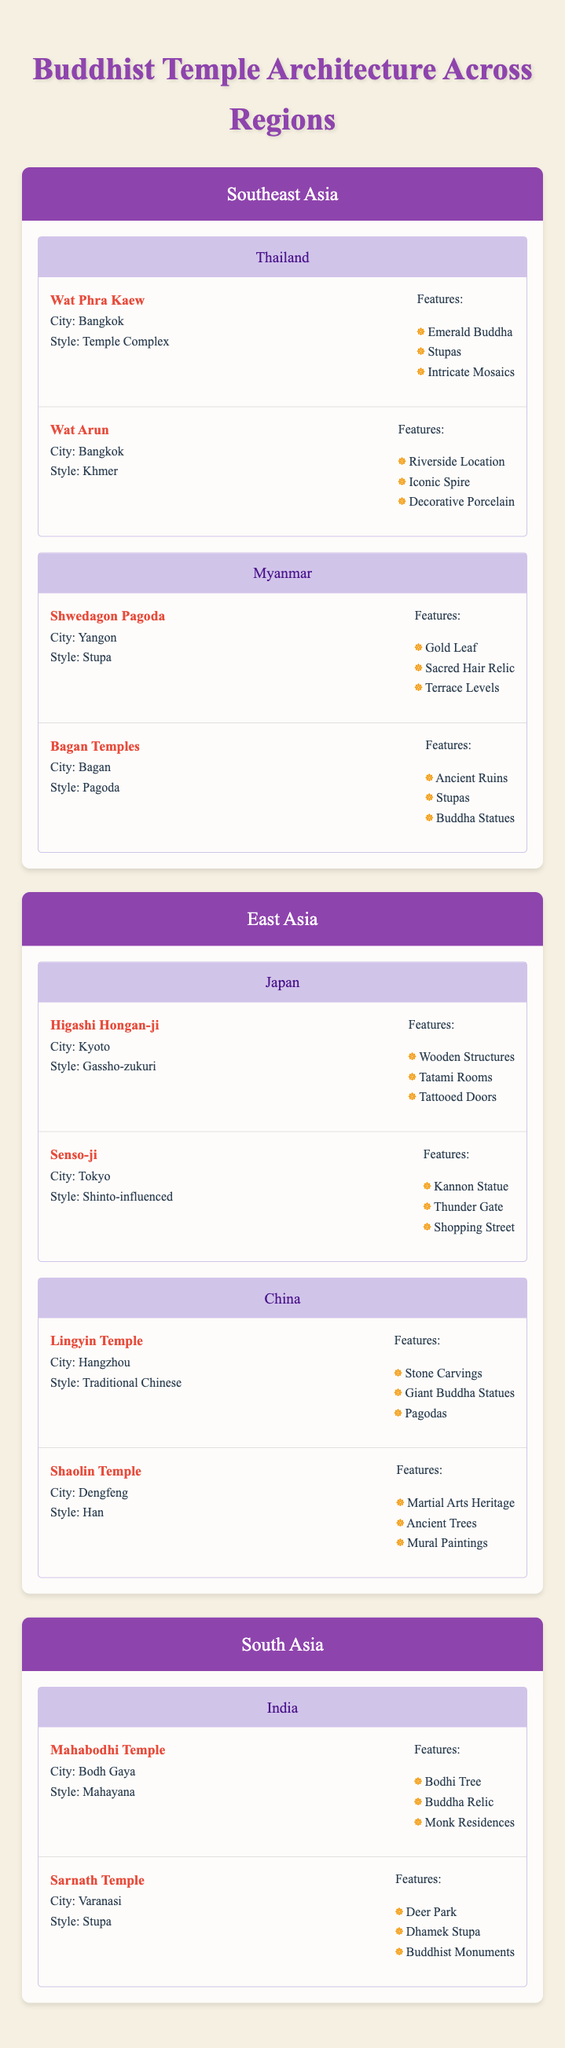What is the style of the Wat Arun temple? Wat Arun is listed in the table under Thailand in the Southeast Asia region, and its style is indicated as "Khmer."
Answer: Khmer Which temple features the Emerald Buddha? Wat Phra Kaew in Bangkok, Thailand features the Emerald Buddha as one of its highlighted features in the table.
Answer: Wat Phra Kaew True or False: The Shwedagon Pagoda is located in India. According to the table, the Shwedagon Pagoda is in Yangon, which is part of Myanmar, not India. Therefore, the statement is false.
Answer: False How many temples in Japan are listed in the table? The table shows two temples in Japan: Higashi Hongan-ji and Senso-ji. Thus, there are 2 temples listed.
Answer: 2 List the unique features of the Mahabodhi Temple. The Mahabodhi Temple lists three features: Bodhi Tree, Buddha Relic, and Monk Residences. Hence, the unique features are those three.
Answer: Bodhi Tree, Buddha Relic, Monk Residences What is the total number of temples in Southeast Asia? In Southeast Asia, the table lists four temples: Wat Phra Kaew and Wat Arun in Thailand, and Shwedagon Pagoda and Bagan Temples in Myanmar. Summing these gives a total of 4 temples.
Answer: 4 Which country has temples with traditional Chinese style? According to the table, Lingyin Temple in Hangzhou, China, showcases the Traditional Chinese style in its classification.
Answer: China Does the Senso-ji temple have a shopping street as one of its features? The table confirms that the Senso-ji temple includes a shopping street among its features, making the statement true.
Answer: Yes Which temple has the most features listed among those in Myanmar? Comparing the features of the Shwedagon Pagoda (Gold Leaf, Sacred Hair Relic, Terrace Levels) and Bagan Temples (Ancient Ruins, Stupas, Buddha Statues), both have three features each, leading to the conclusion that they are equal.
Answer: Equal 